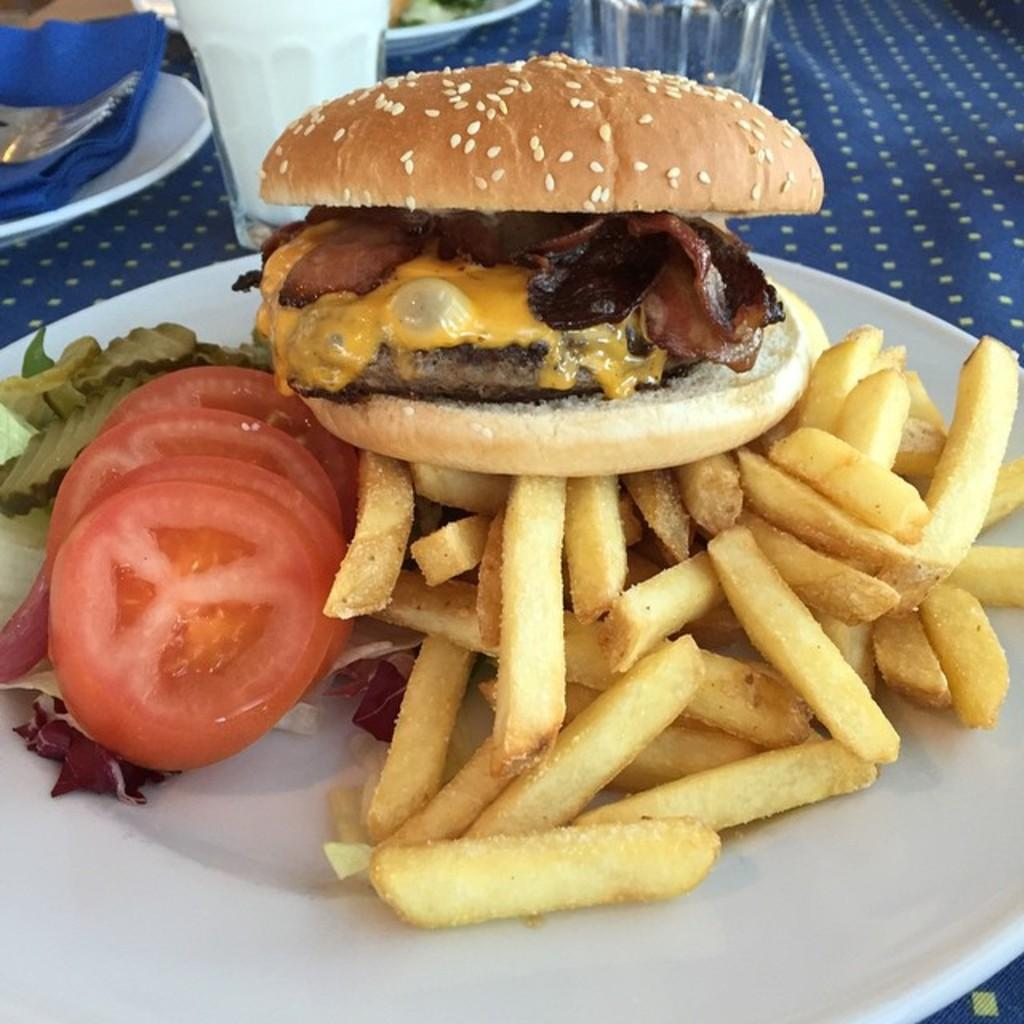What is placed on the table in the image? There are eatables placed on a table. How many glasses are visible on the table? There are two glasses on the table. Can you describe any other objects present on the table? There are other objects present on the table, but their specific details are not mentioned in the provided facts. What type of steel is used to manufacture the team's equipment in the image? There is no team or equipment present in the image, so it is not possible to determine the type of steel used. 